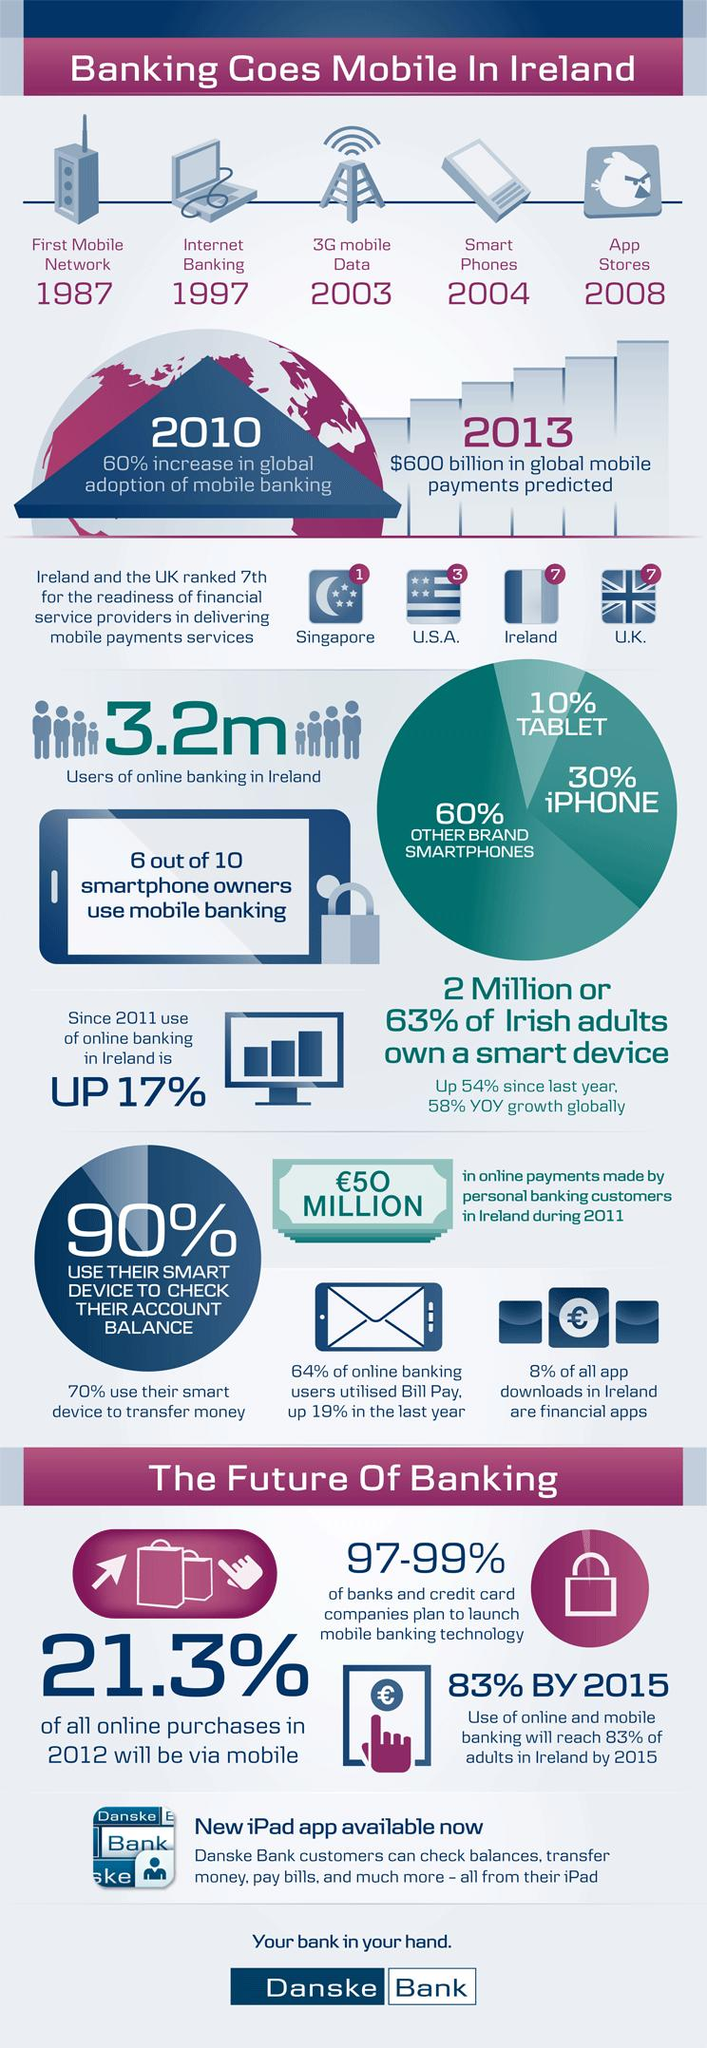List a handful of essential elements in this visual. In 2012, it is expected that a significant percentage of online purchases will be made through mobile devices, with 21.3% of all online purchases being made via mobile. In Ireland, approximately 3.2 million people use online banking, representing a significant portion of the population. Since 2004, smartphones have been widely available in Ireland. In 1997, internet banking was introduced. In the year that saw a 60% increase in worldwide adoption of mobile banking, 2010 was the answer. 